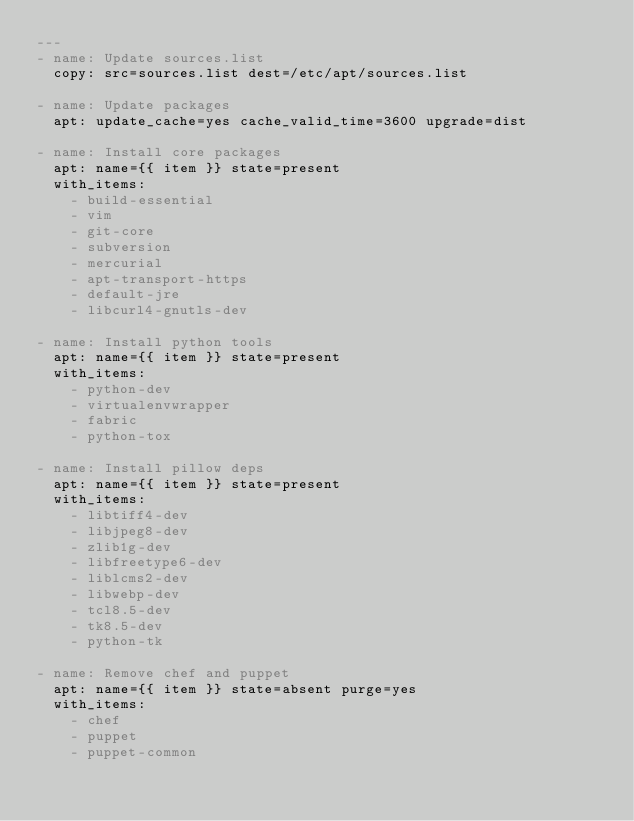Convert code to text. <code><loc_0><loc_0><loc_500><loc_500><_YAML_>---
- name: Update sources.list
  copy: src=sources.list dest=/etc/apt/sources.list

- name: Update packages
  apt: update_cache=yes cache_valid_time=3600 upgrade=dist

- name: Install core packages
  apt: name={{ item }} state=present
  with_items:
    - build-essential
    - vim
    - git-core
    - subversion
    - mercurial
    - apt-transport-https
    - default-jre
    - libcurl4-gnutls-dev

- name: Install python tools
  apt: name={{ item }} state=present
  with_items:
    - python-dev
    - virtualenvwrapper
    - fabric
    - python-tox

- name: Install pillow deps
  apt: name={{ item }} state=present
  with_items:
    - libtiff4-dev
    - libjpeg8-dev
    - zlib1g-dev
    - libfreetype6-dev
    - liblcms2-dev
    - libwebp-dev
    - tcl8.5-dev
    - tk8.5-dev
    - python-tk

- name: Remove chef and puppet
  apt: name={{ item }} state=absent purge=yes
  with_items:
    - chef
    - puppet
    - puppet-common
</code> 